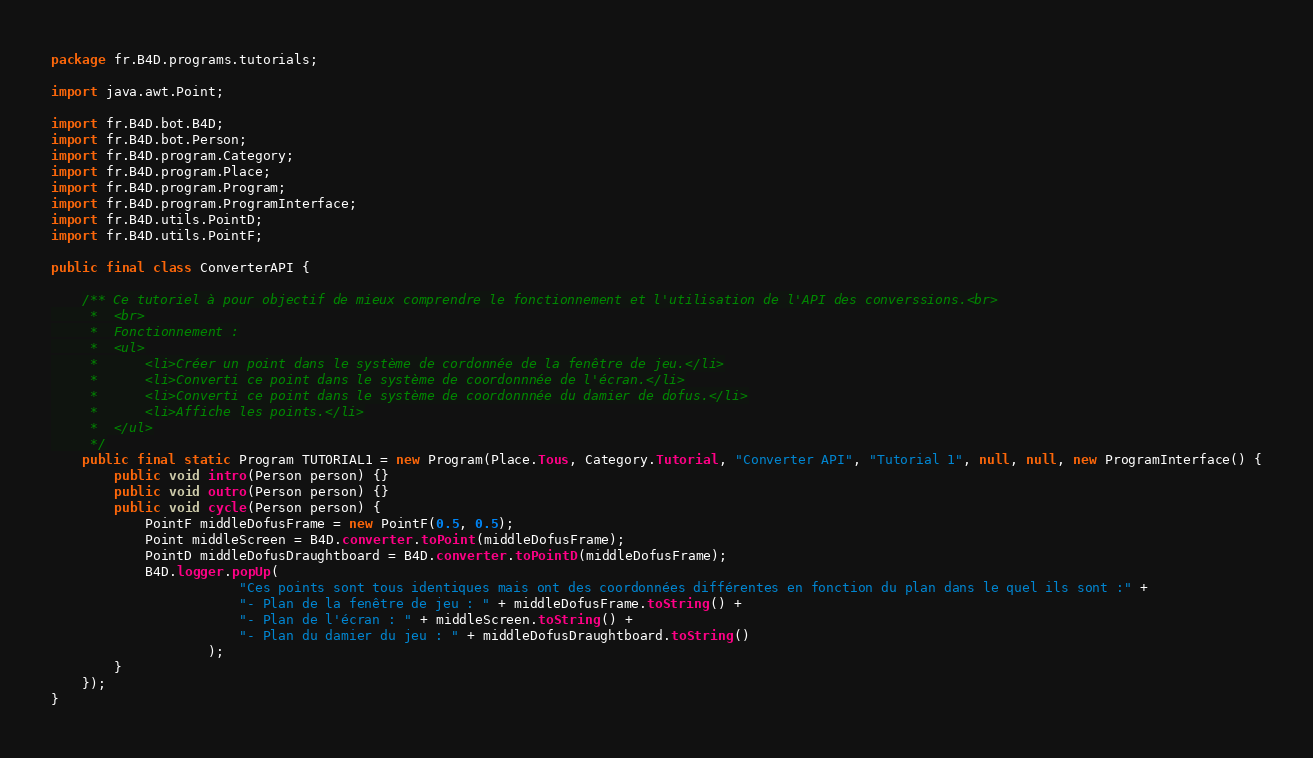<code> <loc_0><loc_0><loc_500><loc_500><_Java_>package fr.B4D.programs.tutorials;

import java.awt.Point;

import fr.B4D.bot.B4D;
import fr.B4D.bot.Person;
import fr.B4D.program.Category;
import fr.B4D.program.Place;
import fr.B4D.program.Program;
import fr.B4D.program.ProgramInterface;
import fr.B4D.utils.PointD;
import fr.B4D.utils.PointF;

public final class ConverterAPI {	

	/** Ce tutoriel à pour objectif de mieux comprendre le fonctionnement et l'utilisation de l'API des converssions.<br>
	 *  <br>
	 *  Fonctionnement :
	 *  <ul>
	 *  	<li>Créer un point dans le système de cordonnée de la fenêtre de jeu.</li>
	 *  	<li>Converti ce point dans le système de coordonnnée de l'écran.</li>
	 *  	<li>Converti ce point dans le système de coordonnnée du damier de dofus.</li>
	 *  	<li>Affiche les points.</li>
	 *  </ul>
	 */
	public final static Program TUTORIAL1 = new Program(Place.Tous, Category.Tutorial, "Converter API", "Tutorial 1", null, null, new ProgramInterface() {
		public void intro(Person person) {}
		public void outro(Person person) {}
		public void cycle(Person person) {			
			PointF middleDofusFrame = new PointF(0.5, 0.5);
			Point middleScreen = B4D.converter.toPoint(middleDofusFrame);
			PointD middleDofusDraughtboard = B4D.converter.toPointD(middleDofusFrame);
			B4D.logger.popUp(
						"Ces points sont tous identiques mais ont des coordonnées différentes en fonction du plan dans le quel ils sont :" +
						"- Plan de la fenêtre de jeu : " + middleDofusFrame.toString() +
						"- Plan de l'écran : " + middleScreen.toString() +
						"- Plan du damier du jeu : " + middleDofusDraughtboard.toString()
					);
		}
	});
}
</code> 